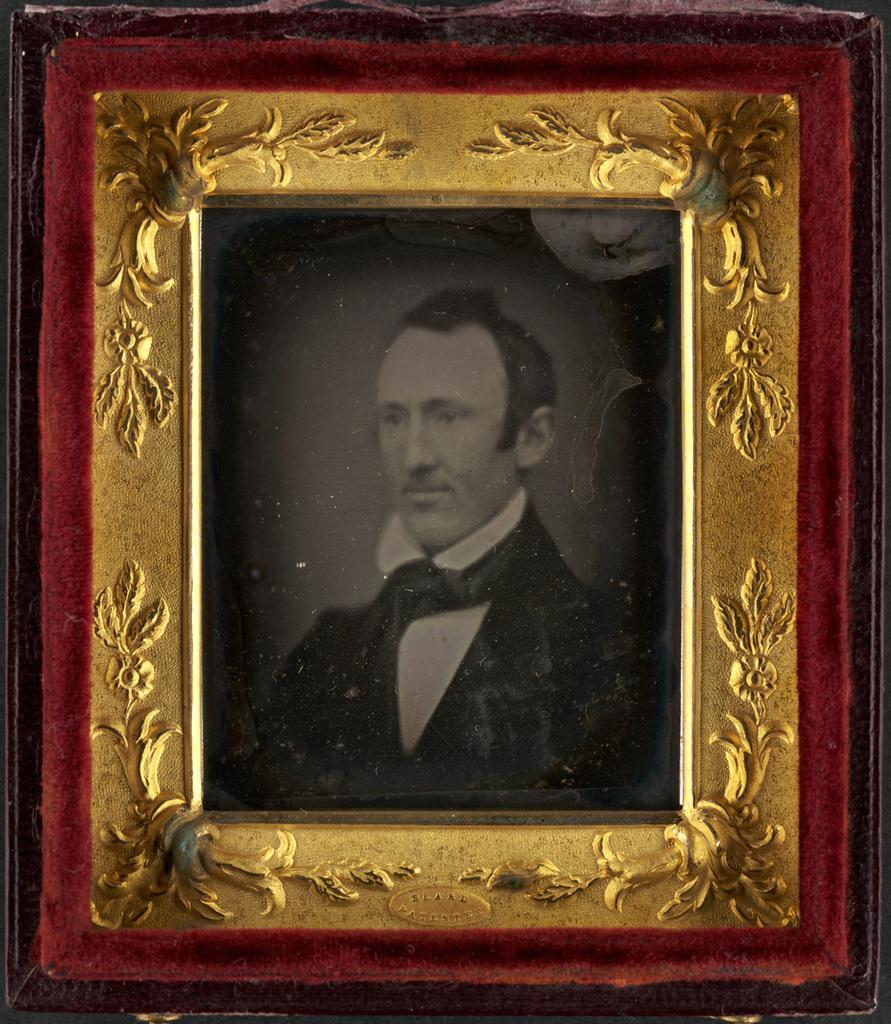What object in the image contains a photo? There is a photo frame in the image. What is depicted in the photo inside the frame? The photo contains a man. What is the man in the photo wearing? The man in the photo is wearing a suit. What type of cabbage can be seen growing in the background of the image? There is no cabbage present in the image; it only features a photo frame with a photo of a man wearing a suit. How many waves can be seen crashing on the shore in the image? There is no reference to waves or a shore in the image; it only features a photo frame with a photo of a man wearing a suit. 